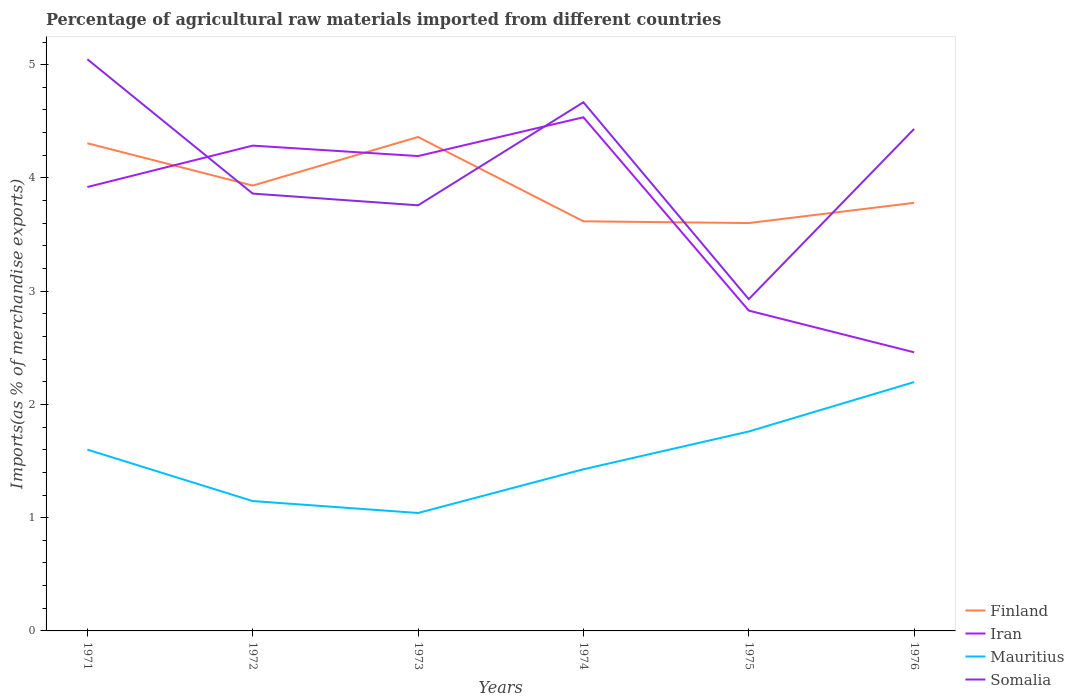How many different coloured lines are there?
Your answer should be compact. 4. Is the number of lines equal to the number of legend labels?
Your answer should be compact. Yes. Across all years, what is the maximum percentage of imports to different countries in Mauritius?
Your answer should be very brief. 1.04. In which year was the percentage of imports to different countries in Iran maximum?
Make the answer very short. 1976. What is the total percentage of imports to different countries in Finland in the graph?
Offer a very short reply. 0.76. What is the difference between the highest and the second highest percentage of imports to different countries in Finland?
Provide a succinct answer. 0.76. Is the percentage of imports to different countries in Finland strictly greater than the percentage of imports to different countries in Somalia over the years?
Your response must be concise. No. How many years are there in the graph?
Ensure brevity in your answer.  6. Are the values on the major ticks of Y-axis written in scientific E-notation?
Offer a very short reply. No. How are the legend labels stacked?
Your answer should be compact. Vertical. What is the title of the graph?
Your answer should be compact. Percentage of agricultural raw materials imported from different countries. What is the label or title of the X-axis?
Provide a succinct answer. Years. What is the label or title of the Y-axis?
Provide a short and direct response. Imports(as % of merchandise exports). What is the Imports(as % of merchandise exports) in Finland in 1971?
Keep it short and to the point. 4.31. What is the Imports(as % of merchandise exports) of Iran in 1971?
Ensure brevity in your answer.  3.92. What is the Imports(as % of merchandise exports) in Mauritius in 1971?
Make the answer very short. 1.6. What is the Imports(as % of merchandise exports) of Somalia in 1971?
Ensure brevity in your answer.  5.05. What is the Imports(as % of merchandise exports) of Finland in 1972?
Provide a short and direct response. 3.93. What is the Imports(as % of merchandise exports) in Iran in 1972?
Provide a short and direct response. 4.29. What is the Imports(as % of merchandise exports) of Mauritius in 1972?
Keep it short and to the point. 1.15. What is the Imports(as % of merchandise exports) of Somalia in 1972?
Provide a short and direct response. 3.86. What is the Imports(as % of merchandise exports) in Finland in 1973?
Give a very brief answer. 4.36. What is the Imports(as % of merchandise exports) in Iran in 1973?
Your answer should be compact. 4.19. What is the Imports(as % of merchandise exports) in Mauritius in 1973?
Offer a terse response. 1.04. What is the Imports(as % of merchandise exports) in Somalia in 1973?
Your answer should be compact. 3.76. What is the Imports(as % of merchandise exports) in Finland in 1974?
Make the answer very short. 3.62. What is the Imports(as % of merchandise exports) of Iran in 1974?
Provide a short and direct response. 4.54. What is the Imports(as % of merchandise exports) of Mauritius in 1974?
Your response must be concise. 1.43. What is the Imports(as % of merchandise exports) in Somalia in 1974?
Your answer should be compact. 4.67. What is the Imports(as % of merchandise exports) in Finland in 1975?
Provide a succinct answer. 3.6. What is the Imports(as % of merchandise exports) of Iran in 1975?
Your response must be concise. 2.83. What is the Imports(as % of merchandise exports) of Mauritius in 1975?
Your response must be concise. 1.76. What is the Imports(as % of merchandise exports) of Somalia in 1975?
Keep it short and to the point. 2.93. What is the Imports(as % of merchandise exports) in Finland in 1976?
Your answer should be very brief. 3.78. What is the Imports(as % of merchandise exports) in Iran in 1976?
Ensure brevity in your answer.  2.46. What is the Imports(as % of merchandise exports) of Mauritius in 1976?
Your answer should be very brief. 2.2. What is the Imports(as % of merchandise exports) of Somalia in 1976?
Your response must be concise. 4.43. Across all years, what is the maximum Imports(as % of merchandise exports) of Finland?
Ensure brevity in your answer.  4.36. Across all years, what is the maximum Imports(as % of merchandise exports) in Iran?
Make the answer very short. 4.54. Across all years, what is the maximum Imports(as % of merchandise exports) in Mauritius?
Your response must be concise. 2.2. Across all years, what is the maximum Imports(as % of merchandise exports) in Somalia?
Give a very brief answer. 5.05. Across all years, what is the minimum Imports(as % of merchandise exports) in Finland?
Your answer should be compact. 3.6. Across all years, what is the minimum Imports(as % of merchandise exports) in Iran?
Ensure brevity in your answer.  2.46. Across all years, what is the minimum Imports(as % of merchandise exports) of Mauritius?
Make the answer very short. 1.04. Across all years, what is the minimum Imports(as % of merchandise exports) in Somalia?
Make the answer very short. 2.93. What is the total Imports(as % of merchandise exports) of Finland in the graph?
Provide a succinct answer. 23.6. What is the total Imports(as % of merchandise exports) in Iran in the graph?
Ensure brevity in your answer.  22.22. What is the total Imports(as % of merchandise exports) of Mauritius in the graph?
Your answer should be compact. 9.17. What is the total Imports(as % of merchandise exports) in Somalia in the graph?
Offer a terse response. 24.7. What is the difference between the Imports(as % of merchandise exports) in Finland in 1971 and that in 1972?
Make the answer very short. 0.37. What is the difference between the Imports(as % of merchandise exports) in Iran in 1971 and that in 1972?
Make the answer very short. -0.37. What is the difference between the Imports(as % of merchandise exports) of Mauritius in 1971 and that in 1972?
Provide a short and direct response. 0.45. What is the difference between the Imports(as % of merchandise exports) in Somalia in 1971 and that in 1972?
Offer a terse response. 1.19. What is the difference between the Imports(as % of merchandise exports) of Finland in 1971 and that in 1973?
Your answer should be very brief. -0.06. What is the difference between the Imports(as % of merchandise exports) of Iran in 1971 and that in 1973?
Your response must be concise. -0.27. What is the difference between the Imports(as % of merchandise exports) in Mauritius in 1971 and that in 1973?
Provide a succinct answer. 0.56. What is the difference between the Imports(as % of merchandise exports) of Somalia in 1971 and that in 1973?
Ensure brevity in your answer.  1.29. What is the difference between the Imports(as % of merchandise exports) of Finland in 1971 and that in 1974?
Offer a very short reply. 0.69. What is the difference between the Imports(as % of merchandise exports) of Iran in 1971 and that in 1974?
Ensure brevity in your answer.  -0.62. What is the difference between the Imports(as % of merchandise exports) of Mauritius in 1971 and that in 1974?
Offer a very short reply. 0.17. What is the difference between the Imports(as % of merchandise exports) of Somalia in 1971 and that in 1974?
Offer a terse response. 0.38. What is the difference between the Imports(as % of merchandise exports) of Finland in 1971 and that in 1975?
Provide a short and direct response. 0.7. What is the difference between the Imports(as % of merchandise exports) in Iran in 1971 and that in 1975?
Offer a terse response. 1.09. What is the difference between the Imports(as % of merchandise exports) in Mauritius in 1971 and that in 1975?
Provide a succinct answer. -0.16. What is the difference between the Imports(as % of merchandise exports) of Somalia in 1971 and that in 1975?
Offer a terse response. 2.12. What is the difference between the Imports(as % of merchandise exports) in Finland in 1971 and that in 1976?
Give a very brief answer. 0.53. What is the difference between the Imports(as % of merchandise exports) in Iran in 1971 and that in 1976?
Your answer should be very brief. 1.46. What is the difference between the Imports(as % of merchandise exports) of Mauritius in 1971 and that in 1976?
Your answer should be very brief. -0.6. What is the difference between the Imports(as % of merchandise exports) of Somalia in 1971 and that in 1976?
Ensure brevity in your answer.  0.62. What is the difference between the Imports(as % of merchandise exports) in Finland in 1972 and that in 1973?
Your answer should be very brief. -0.43. What is the difference between the Imports(as % of merchandise exports) of Iran in 1972 and that in 1973?
Your response must be concise. 0.09. What is the difference between the Imports(as % of merchandise exports) of Mauritius in 1972 and that in 1973?
Your answer should be compact. 0.11. What is the difference between the Imports(as % of merchandise exports) in Somalia in 1972 and that in 1973?
Keep it short and to the point. 0.1. What is the difference between the Imports(as % of merchandise exports) of Finland in 1972 and that in 1974?
Ensure brevity in your answer.  0.32. What is the difference between the Imports(as % of merchandise exports) of Iran in 1972 and that in 1974?
Your answer should be compact. -0.25. What is the difference between the Imports(as % of merchandise exports) of Mauritius in 1972 and that in 1974?
Keep it short and to the point. -0.28. What is the difference between the Imports(as % of merchandise exports) in Somalia in 1972 and that in 1974?
Provide a succinct answer. -0.81. What is the difference between the Imports(as % of merchandise exports) in Finland in 1972 and that in 1975?
Provide a short and direct response. 0.33. What is the difference between the Imports(as % of merchandise exports) of Iran in 1972 and that in 1975?
Provide a succinct answer. 1.46. What is the difference between the Imports(as % of merchandise exports) in Mauritius in 1972 and that in 1975?
Provide a succinct answer. -0.61. What is the difference between the Imports(as % of merchandise exports) of Somalia in 1972 and that in 1975?
Keep it short and to the point. 0.93. What is the difference between the Imports(as % of merchandise exports) in Finland in 1972 and that in 1976?
Offer a very short reply. 0.15. What is the difference between the Imports(as % of merchandise exports) of Iran in 1972 and that in 1976?
Make the answer very short. 1.82. What is the difference between the Imports(as % of merchandise exports) in Mauritius in 1972 and that in 1976?
Your response must be concise. -1.05. What is the difference between the Imports(as % of merchandise exports) of Somalia in 1972 and that in 1976?
Ensure brevity in your answer.  -0.57. What is the difference between the Imports(as % of merchandise exports) in Finland in 1973 and that in 1974?
Your answer should be very brief. 0.74. What is the difference between the Imports(as % of merchandise exports) of Iran in 1973 and that in 1974?
Offer a very short reply. -0.34. What is the difference between the Imports(as % of merchandise exports) of Mauritius in 1973 and that in 1974?
Keep it short and to the point. -0.39. What is the difference between the Imports(as % of merchandise exports) of Somalia in 1973 and that in 1974?
Keep it short and to the point. -0.91. What is the difference between the Imports(as % of merchandise exports) in Finland in 1973 and that in 1975?
Give a very brief answer. 0.76. What is the difference between the Imports(as % of merchandise exports) in Iran in 1973 and that in 1975?
Offer a terse response. 1.36. What is the difference between the Imports(as % of merchandise exports) in Mauritius in 1973 and that in 1975?
Ensure brevity in your answer.  -0.72. What is the difference between the Imports(as % of merchandise exports) of Somalia in 1973 and that in 1975?
Your answer should be compact. 0.83. What is the difference between the Imports(as % of merchandise exports) of Finland in 1973 and that in 1976?
Provide a short and direct response. 0.58. What is the difference between the Imports(as % of merchandise exports) of Iran in 1973 and that in 1976?
Keep it short and to the point. 1.73. What is the difference between the Imports(as % of merchandise exports) of Mauritius in 1973 and that in 1976?
Make the answer very short. -1.16. What is the difference between the Imports(as % of merchandise exports) of Somalia in 1973 and that in 1976?
Your answer should be compact. -0.67. What is the difference between the Imports(as % of merchandise exports) in Finland in 1974 and that in 1975?
Make the answer very short. 0.02. What is the difference between the Imports(as % of merchandise exports) of Iran in 1974 and that in 1975?
Give a very brief answer. 1.71. What is the difference between the Imports(as % of merchandise exports) in Mauritius in 1974 and that in 1975?
Provide a short and direct response. -0.33. What is the difference between the Imports(as % of merchandise exports) in Somalia in 1974 and that in 1975?
Ensure brevity in your answer.  1.74. What is the difference between the Imports(as % of merchandise exports) in Finland in 1974 and that in 1976?
Offer a very short reply. -0.16. What is the difference between the Imports(as % of merchandise exports) in Iran in 1974 and that in 1976?
Keep it short and to the point. 2.08. What is the difference between the Imports(as % of merchandise exports) of Mauritius in 1974 and that in 1976?
Make the answer very short. -0.77. What is the difference between the Imports(as % of merchandise exports) in Somalia in 1974 and that in 1976?
Offer a very short reply. 0.24. What is the difference between the Imports(as % of merchandise exports) in Finland in 1975 and that in 1976?
Keep it short and to the point. -0.18. What is the difference between the Imports(as % of merchandise exports) in Iran in 1975 and that in 1976?
Offer a very short reply. 0.37. What is the difference between the Imports(as % of merchandise exports) of Mauritius in 1975 and that in 1976?
Offer a terse response. -0.44. What is the difference between the Imports(as % of merchandise exports) in Somalia in 1975 and that in 1976?
Keep it short and to the point. -1.5. What is the difference between the Imports(as % of merchandise exports) of Finland in 1971 and the Imports(as % of merchandise exports) of Iran in 1972?
Offer a very short reply. 0.02. What is the difference between the Imports(as % of merchandise exports) of Finland in 1971 and the Imports(as % of merchandise exports) of Mauritius in 1972?
Make the answer very short. 3.16. What is the difference between the Imports(as % of merchandise exports) of Finland in 1971 and the Imports(as % of merchandise exports) of Somalia in 1972?
Keep it short and to the point. 0.44. What is the difference between the Imports(as % of merchandise exports) of Iran in 1971 and the Imports(as % of merchandise exports) of Mauritius in 1972?
Offer a terse response. 2.77. What is the difference between the Imports(as % of merchandise exports) in Iran in 1971 and the Imports(as % of merchandise exports) in Somalia in 1972?
Make the answer very short. 0.06. What is the difference between the Imports(as % of merchandise exports) of Mauritius in 1971 and the Imports(as % of merchandise exports) of Somalia in 1972?
Provide a short and direct response. -2.26. What is the difference between the Imports(as % of merchandise exports) in Finland in 1971 and the Imports(as % of merchandise exports) in Iran in 1973?
Provide a succinct answer. 0.11. What is the difference between the Imports(as % of merchandise exports) in Finland in 1971 and the Imports(as % of merchandise exports) in Mauritius in 1973?
Ensure brevity in your answer.  3.26. What is the difference between the Imports(as % of merchandise exports) in Finland in 1971 and the Imports(as % of merchandise exports) in Somalia in 1973?
Give a very brief answer. 0.55. What is the difference between the Imports(as % of merchandise exports) of Iran in 1971 and the Imports(as % of merchandise exports) of Mauritius in 1973?
Give a very brief answer. 2.88. What is the difference between the Imports(as % of merchandise exports) of Iran in 1971 and the Imports(as % of merchandise exports) of Somalia in 1973?
Offer a very short reply. 0.16. What is the difference between the Imports(as % of merchandise exports) in Mauritius in 1971 and the Imports(as % of merchandise exports) in Somalia in 1973?
Provide a succinct answer. -2.16. What is the difference between the Imports(as % of merchandise exports) in Finland in 1971 and the Imports(as % of merchandise exports) in Iran in 1974?
Provide a succinct answer. -0.23. What is the difference between the Imports(as % of merchandise exports) in Finland in 1971 and the Imports(as % of merchandise exports) in Mauritius in 1974?
Your answer should be very brief. 2.88. What is the difference between the Imports(as % of merchandise exports) in Finland in 1971 and the Imports(as % of merchandise exports) in Somalia in 1974?
Make the answer very short. -0.36. What is the difference between the Imports(as % of merchandise exports) in Iran in 1971 and the Imports(as % of merchandise exports) in Mauritius in 1974?
Offer a terse response. 2.49. What is the difference between the Imports(as % of merchandise exports) in Iran in 1971 and the Imports(as % of merchandise exports) in Somalia in 1974?
Make the answer very short. -0.75. What is the difference between the Imports(as % of merchandise exports) of Mauritius in 1971 and the Imports(as % of merchandise exports) of Somalia in 1974?
Offer a terse response. -3.07. What is the difference between the Imports(as % of merchandise exports) in Finland in 1971 and the Imports(as % of merchandise exports) in Iran in 1975?
Offer a very short reply. 1.48. What is the difference between the Imports(as % of merchandise exports) in Finland in 1971 and the Imports(as % of merchandise exports) in Mauritius in 1975?
Your answer should be compact. 2.55. What is the difference between the Imports(as % of merchandise exports) of Finland in 1971 and the Imports(as % of merchandise exports) of Somalia in 1975?
Your answer should be compact. 1.38. What is the difference between the Imports(as % of merchandise exports) in Iran in 1971 and the Imports(as % of merchandise exports) in Mauritius in 1975?
Give a very brief answer. 2.16. What is the difference between the Imports(as % of merchandise exports) in Iran in 1971 and the Imports(as % of merchandise exports) in Somalia in 1975?
Give a very brief answer. 0.99. What is the difference between the Imports(as % of merchandise exports) in Mauritius in 1971 and the Imports(as % of merchandise exports) in Somalia in 1975?
Your response must be concise. -1.33. What is the difference between the Imports(as % of merchandise exports) in Finland in 1971 and the Imports(as % of merchandise exports) in Iran in 1976?
Offer a terse response. 1.85. What is the difference between the Imports(as % of merchandise exports) in Finland in 1971 and the Imports(as % of merchandise exports) in Mauritius in 1976?
Your answer should be very brief. 2.11. What is the difference between the Imports(as % of merchandise exports) of Finland in 1971 and the Imports(as % of merchandise exports) of Somalia in 1976?
Offer a very short reply. -0.13. What is the difference between the Imports(as % of merchandise exports) in Iran in 1971 and the Imports(as % of merchandise exports) in Mauritius in 1976?
Your answer should be compact. 1.72. What is the difference between the Imports(as % of merchandise exports) of Iran in 1971 and the Imports(as % of merchandise exports) of Somalia in 1976?
Ensure brevity in your answer.  -0.51. What is the difference between the Imports(as % of merchandise exports) in Mauritius in 1971 and the Imports(as % of merchandise exports) in Somalia in 1976?
Your answer should be compact. -2.83. What is the difference between the Imports(as % of merchandise exports) of Finland in 1972 and the Imports(as % of merchandise exports) of Iran in 1973?
Keep it short and to the point. -0.26. What is the difference between the Imports(as % of merchandise exports) of Finland in 1972 and the Imports(as % of merchandise exports) of Mauritius in 1973?
Your answer should be very brief. 2.89. What is the difference between the Imports(as % of merchandise exports) of Finland in 1972 and the Imports(as % of merchandise exports) of Somalia in 1973?
Provide a succinct answer. 0.17. What is the difference between the Imports(as % of merchandise exports) of Iran in 1972 and the Imports(as % of merchandise exports) of Mauritius in 1973?
Provide a short and direct response. 3.24. What is the difference between the Imports(as % of merchandise exports) in Iran in 1972 and the Imports(as % of merchandise exports) in Somalia in 1973?
Offer a terse response. 0.53. What is the difference between the Imports(as % of merchandise exports) in Mauritius in 1972 and the Imports(as % of merchandise exports) in Somalia in 1973?
Make the answer very short. -2.61. What is the difference between the Imports(as % of merchandise exports) of Finland in 1972 and the Imports(as % of merchandise exports) of Iran in 1974?
Keep it short and to the point. -0.6. What is the difference between the Imports(as % of merchandise exports) of Finland in 1972 and the Imports(as % of merchandise exports) of Mauritius in 1974?
Provide a short and direct response. 2.51. What is the difference between the Imports(as % of merchandise exports) in Finland in 1972 and the Imports(as % of merchandise exports) in Somalia in 1974?
Make the answer very short. -0.74. What is the difference between the Imports(as % of merchandise exports) in Iran in 1972 and the Imports(as % of merchandise exports) in Mauritius in 1974?
Keep it short and to the point. 2.86. What is the difference between the Imports(as % of merchandise exports) in Iran in 1972 and the Imports(as % of merchandise exports) in Somalia in 1974?
Provide a succinct answer. -0.38. What is the difference between the Imports(as % of merchandise exports) in Mauritius in 1972 and the Imports(as % of merchandise exports) in Somalia in 1974?
Give a very brief answer. -3.52. What is the difference between the Imports(as % of merchandise exports) in Finland in 1972 and the Imports(as % of merchandise exports) in Iran in 1975?
Keep it short and to the point. 1.1. What is the difference between the Imports(as % of merchandise exports) of Finland in 1972 and the Imports(as % of merchandise exports) of Mauritius in 1975?
Your response must be concise. 2.17. What is the difference between the Imports(as % of merchandise exports) of Finland in 1972 and the Imports(as % of merchandise exports) of Somalia in 1975?
Give a very brief answer. 1. What is the difference between the Imports(as % of merchandise exports) of Iran in 1972 and the Imports(as % of merchandise exports) of Mauritius in 1975?
Your answer should be very brief. 2.52. What is the difference between the Imports(as % of merchandise exports) of Iran in 1972 and the Imports(as % of merchandise exports) of Somalia in 1975?
Your response must be concise. 1.36. What is the difference between the Imports(as % of merchandise exports) in Mauritius in 1972 and the Imports(as % of merchandise exports) in Somalia in 1975?
Your answer should be very brief. -1.78. What is the difference between the Imports(as % of merchandise exports) of Finland in 1972 and the Imports(as % of merchandise exports) of Iran in 1976?
Ensure brevity in your answer.  1.47. What is the difference between the Imports(as % of merchandise exports) in Finland in 1972 and the Imports(as % of merchandise exports) in Mauritius in 1976?
Your answer should be very brief. 1.74. What is the difference between the Imports(as % of merchandise exports) in Finland in 1972 and the Imports(as % of merchandise exports) in Somalia in 1976?
Your response must be concise. -0.5. What is the difference between the Imports(as % of merchandise exports) in Iran in 1972 and the Imports(as % of merchandise exports) in Mauritius in 1976?
Give a very brief answer. 2.09. What is the difference between the Imports(as % of merchandise exports) in Iran in 1972 and the Imports(as % of merchandise exports) in Somalia in 1976?
Offer a very short reply. -0.15. What is the difference between the Imports(as % of merchandise exports) in Mauritius in 1972 and the Imports(as % of merchandise exports) in Somalia in 1976?
Offer a very short reply. -3.29. What is the difference between the Imports(as % of merchandise exports) in Finland in 1973 and the Imports(as % of merchandise exports) in Iran in 1974?
Keep it short and to the point. -0.17. What is the difference between the Imports(as % of merchandise exports) of Finland in 1973 and the Imports(as % of merchandise exports) of Mauritius in 1974?
Give a very brief answer. 2.93. What is the difference between the Imports(as % of merchandise exports) of Finland in 1973 and the Imports(as % of merchandise exports) of Somalia in 1974?
Your answer should be compact. -0.31. What is the difference between the Imports(as % of merchandise exports) in Iran in 1973 and the Imports(as % of merchandise exports) in Mauritius in 1974?
Offer a terse response. 2.77. What is the difference between the Imports(as % of merchandise exports) of Iran in 1973 and the Imports(as % of merchandise exports) of Somalia in 1974?
Your answer should be very brief. -0.47. What is the difference between the Imports(as % of merchandise exports) of Mauritius in 1973 and the Imports(as % of merchandise exports) of Somalia in 1974?
Your answer should be very brief. -3.63. What is the difference between the Imports(as % of merchandise exports) in Finland in 1973 and the Imports(as % of merchandise exports) in Iran in 1975?
Give a very brief answer. 1.53. What is the difference between the Imports(as % of merchandise exports) of Finland in 1973 and the Imports(as % of merchandise exports) of Mauritius in 1975?
Provide a short and direct response. 2.6. What is the difference between the Imports(as % of merchandise exports) of Finland in 1973 and the Imports(as % of merchandise exports) of Somalia in 1975?
Ensure brevity in your answer.  1.43. What is the difference between the Imports(as % of merchandise exports) of Iran in 1973 and the Imports(as % of merchandise exports) of Mauritius in 1975?
Your answer should be very brief. 2.43. What is the difference between the Imports(as % of merchandise exports) of Iran in 1973 and the Imports(as % of merchandise exports) of Somalia in 1975?
Give a very brief answer. 1.26. What is the difference between the Imports(as % of merchandise exports) of Mauritius in 1973 and the Imports(as % of merchandise exports) of Somalia in 1975?
Ensure brevity in your answer.  -1.89. What is the difference between the Imports(as % of merchandise exports) of Finland in 1973 and the Imports(as % of merchandise exports) of Iran in 1976?
Provide a succinct answer. 1.9. What is the difference between the Imports(as % of merchandise exports) of Finland in 1973 and the Imports(as % of merchandise exports) of Mauritius in 1976?
Your answer should be very brief. 2.16. What is the difference between the Imports(as % of merchandise exports) in Finland in 1973 and the Imports(as % of merchandise exports) in Somalia in 1976?
Your response must be concise. -0.07. What is the difference between the Imports(as % of merchandise exports) in Iran in 1973 and the Imports(as % of merchandise exports) in Mauritius in 1976?
Ensure brevity in your answer.  2. What is the difference between the Imports(as % of merchandise exports) in Iran in 1973 and the Imports(as % of merchandise exports) in Somalia in 1976?
Offer a very short reply. -0.24. What is the difference between the Imports(as % of merchandise exports) in Mauritius in 1973 and the Imports(as % of merchandise exports) in Somalia in 1976?
Provide a succinct answer. -3.39. What is the difference between the Imports(as % of merchandise exports) in Finland in 1974 and the Imports(as % of merchandise exports) in Iran in 1975?
Offer a terse response. 0.79. What is the difference between the Imports(as % of merchandise exports) of Finland in 1974 and the Imports(as % of merchandise exports) of Mauritius in 1975?
Your answer should be compact. 1.86. What is the difference between the Imports(as % of merchandise exports) of Finland in 1974 and the Imports(as % of merchandise exports) of Somalia in 1975?
Offer a terse response. 0.69. What is the difference between the Imports(as % of merchandise exports) in Iran in 1974 and the Imports(as % of merchandise exports) in Mauritius in 1975?
Keep it short and to the point. 2.77. What is the difference between the Imports(as % of merchandise exports) of Iran in 1974 and the Imports(as % of merchandise exports) of Somalia in 1975?
Your answer should be compact. 1.61. What is the difference between the Imports(as % of merchandise exports) in Mauritius in 1974 and the Imports(as % of merchandise exports) in Somalia in 1975?
Your response must be concise. -1.5. What is the difference between the Imports(as % of merchandise exports) in Finland in 1974 and the Imports(as % of merchandise exports) in Iran in 1976?
Offer a terse response. 1.16. What is the difference between the Imports(as % of merchandise exports) in Finland in 1974 and the Imports(as % of merchandise exports) in Mauritius in 1976?
Your response must be concise. 1.42. What is the difference between the Imports(as % of merchandise exports) of Finland in 1974 and the Imports(as % of merchandise exports) of Somalia in 1976?
Offer a terse response. -0.82. What is the difference between the Imports(as % of merchandise exports) in Iran in 1974 and the Imports(as % of merchandise exports) in Mauritius in 1976?
Your answer should be very brief. 2.34. What is the difference between the Imports(as % of merchandise exports) of Iran in 1974 and the Imports(as % of merchandise exports) of Somalia in 1976?
Offer a very short reply. 0.1. What is the difference between the Imports(as % of merchandise exports) in Mauritius in 1974 and the Imports(as % of merchandise exports) in Somalia in 1976?
Ensure brevity in your answer.  -3.01. What is the difference between the Imports(as % of merchandise exports) of Finland in 1975 and the Imports(as % of merchandise exports) of Iran in 1976?
Your answer should be compact. 1.14. What is the difference between the Imports(as % of merchandise exports) of Finland in 1975 and the Imports(as % of merchandise exports) of Mauritius in 1976?
Keep it short and to the point. 1.4. What is the difference between the Imports(as % of merchandise exports) in Finland in 1975 and the Imports(as % of merchandise exports) in Somalia in 1976?
Provide a short and direct response. -0.83. What is the difference between the Imports(as % of merchandise exports) of Iran in 1975 and the Imports(as % of merchandise exports) of Mauritius in 1976?
Provide a succinct answer. 0.63. What is the difference between the Imports(as % of merchandise exports) of Iran in 1975 and the Imports(as % of merchandise exports) of Somalia in 1976?
Provide a short and direct response. -1.6. What is the difference between the Imports(as % of merchandise exports) of Mauritius in 1975 and the Imports(as % of merchandise exports) of Somalia in 1976?
Provide a succinct answer. -2.67. What is the average Imports(as % of merchandise exports) in Finland per year?
Your answer should be very brief. 3.93. What is the average Imports(as % of merchandise exports) of Iran per year?
Make the answer very short. 3.7. What is the average Imports(as % of merchandise exports) of Mauritius per year?
Keep it short and to the point. 1.53. What is the average Imports(as % of merchandise exports) in Somalia per year?
Ensure brevity in your answer.  4.12. In the year 1971, what is the difference between the Imports(as % of merchandise exports) of Finland and Imports(as % of merchandise exports) of Iran?
Your response must be concise. 0.39. In the year 1971, what is the difference between the Imports(as % of merchandise exports) of Finland and Imports(as % of merchandise exports) of Mauritius?
Your response must be concise. 2.71. In the year 1971, what is the difference between the Imports(as % of merchandise exports) of Finland and Imports(as % of merchandise exports) of Somalia?
Keep it short and to the point. -0.74. In the year 1971, what is the difference between the Imports(as % of merchandise exports) in Iran and Imports(as % of merchandise exports) in Mauritius?
Provide a succinct answer. 2.32. In the year 1971, what is the difference between the Imports(as % of merchandise exports) in Iran and Imports(as % of merchandise exports) in Somalia?
Your answer should be compact. -1.13. In the year 1971, what is the difference between the Imports(as % of merchandise exports) of Mauritius and Imports(as % of merchandise exports) of Somalia?
Offer a very short reply. -3.45. In the year 1972, what is the difference between the Imports(as % of merchandise exports) in Finland and Imports(as % of merchandise exports) in Iran?
Your response must be concise. -0.35. In the year 1972, what is the difference between the Imports(as % of merchandise exports) of Finland and Imports(as % of merchandise exports) of Mauritius?
Provide a succinct answer. 2.79. In the year 1972, what is the difference between the Imports(as % of merchandise exports) in Finland and Imports(as % of merchandise exports) in Somalia?
Your response must be concise. 0.07. In the year 1972, what is the difference between the Imports(as % of merchandise exports) in Iran and Imports(as % of merchandise exports) in Mauritius?
Your answer should be compact. 3.14. In the year 1972, what is the difference between the Imports(as % of merchandise exports) in Iran and Imports(as % of merchandise exports) in Somalia?
Keep it short and to the point. 0.42. In the year 1972, what is the difference between the Imports(as % of merchandise exports) of Mauritius and Imports(as % of merchandise exports) of Somalia?
Give a very brief answer. -2.71. In the year 1973, what is the difference between the Imports(as % of merchandise exports) in Finland and Imports(as % of merchandise exports) in Iran?
Make the answer very short. 0.17. In the year 1973, what is the difference between the Imports(as % of merchandise exports) of Finland and Imports(as % of merchandise exports) of Mauritius?
Your response must be concise. 3.32. In the year 1973, what is the difference between the Imports(as % of merchandise exports) in Finland and Imports(as % of merchandise exports) in Somalia?
Offer a very short reply. 0.6. In the year 1973, what is the difference between the Imports(as % of merchandise exports) of Iran and Imports(as % of merchandise exports) of Mauritius?
Offer a very short reply. 3.15. In the year 1973, what is the difference between the Imports(as % of merchandise exports) of Iran and Imports(as % of merchandise exports) of Somalia?
Ensure brevity in your answer.  0.43. In the year 1973, what is the difference between the Imports(as % of merchandise exports) of Mauritius and Imports(as % of merchandise exports) of Somalia?
Provide a short and direct response. -2.72. In the year 1974, what is the difference between the Imports(as % of merchandise exports) of Finland and Imports(as % of merchandise exports) of Iran?
Your response must be concise. -0.92. In the year 1974, what is the difference between the Imports(as % of merchandise exports) of Finland and Imports(as % of merchandise exports) of Mauritius?
Your answer should be very brief. 2.19. In the year 1974, what is the difference between the Imports(as % of merchandise exports) of Finland and Imports(as % of merchandise exports) of Somalia?
Ensure brevity in your answer.  -1.05. In the year 1974, what is the difference between the Imports(as % of merchandise exports) of Iran and Imports(as % of merchandise exports) of Mauritius?
Provide a short and direct response. 3.11. In the year 1974, what is the difference between the Imports(as % of merchandise exports) of Iran and Imports(as % of merchandise exports) of Somalia?
Your response must be concise. -0.13. In the year 1974, what is the difference between the Imports(as % of merchandise exports) of Mauritius and Imports(as % of merchandise exports) of Somalia?
Ensure brevity in your answer.  -3.24. In the year 1975, what is the difference between the Imports(as % of merchandise exports) of Finland and Imports(as % of merchandise exports) of Iran?
Make the answer very short. 0.77. In the year 1975, what is the difference between the Imports(as % of merchandise exports) in Finland and Imports(as % of merchandise exports) in Mauritius?
Provide a succinct answer. 1.84. In the year 1975, what is the difference between the Imports(as % of merchandise exports) of Finland and Imports(as % of merchandise exports) of Somalia?
Provide a succinct answer. 0.67. In the year 1975, what is the difference between the Imports(as % of merchandise exports) in Iran and Imports(as % of merchandise exports) in Mauritius?
Your answer should be very brief. 1.07. In the year 1975, what is the difference between the Imports(as % of merchandise exports) of Iran and Imports(as % of merchandise exports) of Somalia?
Give a very brief answer. -0.1. In the year 1975, what is the difference between the Imports(as % of merchandise exports) of Mauritius and Imports(as % of merchandise exports) of Somalia?
Provide a short and direct response. -1.17. In the year 1976, what is the difference between the Imports(as % of merchandise exports) of Finland and Imports(as % of merchandise exports) of Iran?
Keep it short and to the point. 1.32. In the year 1976, what is the difference between the Imports(as % of merchandise exports) of Finland and Imports(as % of merchandise exports) of Mauritius?
Provide a succinct answer. 1.58. In the year 1976, what is the difference between the Imports(as % of merchandise exports) in Finland and Imports(as % of merchandise exports) in Somalia?
Your answer should be very brief. -0.65. In the year 1976, what is the difference between the Imports(as % of merchandise exports) in Iran and Imports(as % of merchandise exports) in Mauritius?
Offer a very short reply. 0.26. In the year 1976, what is the difference between the Imports(as % of merchandise exports) of Iran and Imports(as % of merchandise exports) of Somalia?
Your response must be concise. -1.97. In the year 1976, what is the difference between the Imports(as % of merchandise exports) in Mauritius and Imports(as % of merchandise exports) in Somalia?
Keep it short and to the point. -2.24. What is the ratio of the Imports(as % of merchandise exports) in Finland in 1971 to that in 1972?
Provide a short and direct response. 1.1. What is the ratio of the Imports(as % of merchandise exports) of Iran in 1971 to that in 1972?
Provide a short and direct response. 0.91. What is the ratio of the Imports(as % of merchandise exports) of Mauritius in 1971 to that in 1972?
Offer a terse response. 1.4. What is the ratio of the Imports(as % of merchandise exports) of Somalia in 1971 to that in 1972?
Your response must be concise. 1.31. What is the ratio of the Imports(as % of merchandise exports) of Finland in 1971 to that in 1973?
Provide a succinct answer. 0.99. What is the ratio of the Imports(as % of merchandise exports) of Iran in 1971 to that in 1973?
Ensure brevity in your answer.  0.93. What is the ratio of the Imports(as % of merchandise exports) in Mauritius in 1971 to that in 1973?
Ensure brevity in your answer.  1.54. What is the ratio of the Imports(as % of merchandise exports) in Somalia in 1971 to that in 1973?
Offer a terse response. 1.34. What is the ratio of the Imports(as % of merchandise exports) of Finland in 1971 to that in 1974?
Give a very brief answer. 1.19. What is the ratio of the Imports(as % of merchandise exports) of Iran in 1971 to that in 1974?
Make the answer very short. 0.86. What is the ratio of the Imports(as % of merchandise exports) of Mauritius in 1971 to that in 1974?
Your answer should be compact. 1.12. What is the ratio of the Imports(as % of merchandise exports) of Somalia in 1971 to that in 1974?
Your answer should be very brief. 1.08. What is the ratio of the Imports(as % of merchandise exports) of Finland in 1971 to that in 1975?
Make the answer very short. 1.2. What is the ratio of the Imports(as % of merchandise exports) of Iran in 1971 to that in 1975?
Make the answer very short. 1.39. What is the ratio of the Imports(as % of merchandise exports) of Mauritius in 1971 to that in 1975?
Provide a short and direct response. 0.91. What is the ratio of the Imports(as % of merchandise exports) of Somalia in 1971 to that in 1975?
Offer a very short reply. 1.72. What is the ratio of the Imports(as % of merchandise exports) in Finland in 1971 to that in 1976?
Your answer should be very brief. 1.14. What is the ratio of the Imports(as % of merchandise exports) of Iran in 1971 to that in 1976?
Your answer should be very brief. 1.59. What is the ratio of the Imports(as % of merchandise exports) of Mauritius in 1971 to that in 1976?
Offer a very short reply. 0.73. What is the ratio of the Imports(as % of merchandise exports) of Somalia in 1971 to that in 1976?
Make the answer very short. 1.14. What is the ratio of the Imports(as % of merchandise exports) of Finland in 1972 to that in 1973?
Offer a very short reply. 0.9. What is the ratio of the Imports(as % of merchandise exports) of Mauritius in 1972 to that in 1973?
Ensure brevity in your answer.  1.1. What is the ratio of the Imports(as % of merchandise exports) of Somalia in 1972 to that in 1973?
Your answer should be compact. 1.03. What is the ratio of the Imports(as % of merchandise exports) in Finland in 1972 to that in 1974?
Provide a succinct answer. 1.09. What is the ratio of the Imports(as % of merchandise exports) in Iran in 1972 to that in 1974?
Give a very brief answer. 0.94. What is the ratio of the Imports(as % of merchandise exports) of Mauritius in 1972 to that in 1974?
Offer a terse response. 0.8. What is the ratio of the Imports(as % of merchandise exports) in Somalia in 1972 to that in 1974?
Give a very brief answer. 0.83. What is the ratio of the Imports(as % of merchandise exports) in Finland in 1972 to that in 1975?
Your answer should be compact. 1.09. What is the ratio of the Imports(as % of merchandise exports) of Iran in 1972 to that in 1975?
Ensure brevity in your answer.  1.51. What is the ratio of the Imports(as % of merchandise exports) of Mauritius in 1972 to that in 1975?
Give a very brief answer. 0.65. What is the ratio of the Imports(as % of merchandise exports) in Somalia in 1972 to that in 1975?
Keep it short and to the point. 1.32. What is the ratio of the Imports(as % of merchandise exports) of Finland in 1972 to that in 1976?
Ensure brevity in your answer.  1.04. What is the ratio of the Imports(as % of merchandise exports) of Iran in 1972 to that in 1976?
Ensure brevity in your answer.  1.74. What is the ratio of the Imports(as % of merchandise exports) in Mauritius in 1972 to that in 1976?
Offer a terse response. 0.52. What is the ratio of the Imports(as % of merchandise exports) of Somalia in 1972 to that in 1976?
Offer a terse response. 0.87. What is the ratio of the Imports(as % of merchandise exports) of Finland in 1973 to that in 1974?
Make the answer very short. 1.21. What is the ratio of the Imports(as % of merchandise exports) of Iran in 1973 to that in 1974?
Keep it short and to the point. 0.92. What is the ratio of the Imports(as % of merchandise exports) of Mauritius in 1973 to that in 1974?
Your response must be concise. 0.73. What is the ratio of the Imports(as % of merchandise exports) in Somalia in 1973 to that in 1974?
Provide a short and direct response. 0.81. What is the ratio of the Imports(as % of merchandise exports) of Finland in 1973 to that in 1975?
Give a very brief answer. 1.21. What is the ratio of the Imports(as % of merchandise exports) in Iran in 1973 to that in 1975?
Make the answer very short. 1.48. What is the ratio of the Imports(as % of merchandise exports) in Mauritius in 1973 to that in 1975?
Make the answer very short. 0.59. What is the ratio of the Imports(as % of merchandise exports) of Somalia in 1973 to that in 1975?
Your answer should be very brief. 1.28. What is the ratio of the Imports(as % of merchandise exports) in Finland in 1973 to that in 1976?
Keep it short and to the point. 1.15. What is the ratio of the Imports(as % of merchandise exports) of Iran in 1973 to that in 1976?
Ensure brevity in your answer.  1.7. What is the ratio of the Imports(as % of merchandise exports) of Mauritius in 1973 to that in 1976?
Give a very brief answer. 0.47. What is the ratio of the Imports(as % of merchandise exports) of Somalia in 1973 to that in 1976?
Provide a succinct answer. 0.85. What is the ratio of the Imports(as % of merchandise exports) of Iran in 1974 to that in 1975?
Keep it short and to the point. 1.6. What is the ratio of the Imports(as % of merchandise exports) in Mauritius in 1974 to that in 1975?
Make the answer very short. 0.81. What is the ratio of the Imports(as % of merchandise exports) of Somalia in 1974 to that in 1975?
Make the answer very short. 1.59. What is the ratio of the Imports(as % of merchandise exports) in Finland in 1974 to that in 1976?
Offer a terse response. 0.96. What is the ratio of the Imports(as % of merchandise exports) in Iran in 1974 to that in 1976?
Ensure brevity in your answer.  1.84. What is the ratio of the Imports(as % of merchandise exports) of Mauritius in 1974 to that in 1976?
Offer a terse response. 0.65. What is the ratio of the Imports(as % of merchandise exports) in Somalia in 1974 to that in 1976?
Give a very brief answer. 1.05. What is the ratio of the Imports(as % of merchandise exports) in Finland in 1975 to that in 1976?
Your response must be concise. 0.95. What is the ratio of the Imports(as % of merchandise exports) of Iran in 1975 to that in 1976?
Provide a succinct answer. 1.15. What is the ratio of the Imports(as % of merchandise exports) of Mauritius in 1975 to that in 1976?
Your response must be concise. 0.8. What is the ratio of the Imports(as % of merchandise exports) in Somalia in 1975 to that in 1976?
Give a very brief answer. 0.66. What is the difference between the highest and the second highest Imports(as % of merchandise exports) of Finland?
Your answer should be compact. 0.06. What is the difference between the highest and the second highest Imports(as % of merchandise exports) of Iran?
Your answer should be compact. 0.25. What is the difference between the highest and the second highest Imports(as % of merchandise exports) of Mauritius?
Provide a short and direct response. 0.44. What is the difference between the highest and the second highest Imports(as % of merchandise exports) in Somalia?
Provide a short and direct response. 0.38. What is the difference between the highest and the lowest Imports(as % of merchandise exports) in Finland?
Ensure brevity in your answer.  0.76. What is the difference between the highest and the lowest Imports(as % of merchandise exports) in Iran?
Your response must be concise. 2.08. What is the difference between the highest and the lowest Imports(as % of merchandise exports) of Mauritius?
Keep it short and to the point. 1.16. What is the difference between the highest and the lowest Imports(as % of merchandise exports) in Somalia?
Provide a succinct answer. 2.12. 